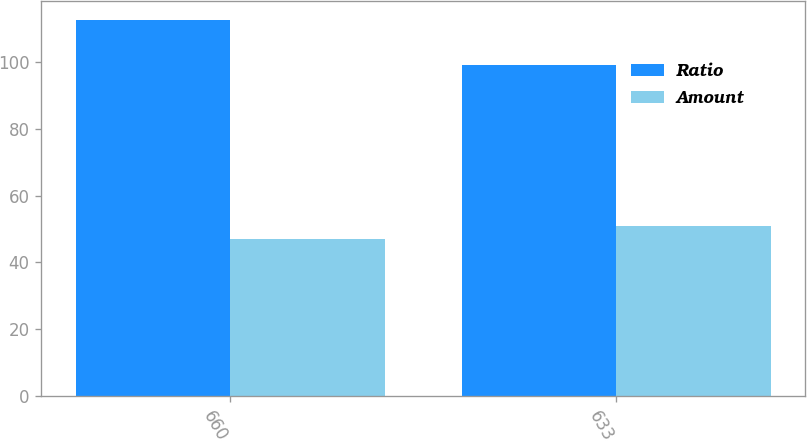Convert chart to OTSL. <chart><loc_0><loc_0><loc_500><loc_500><stacked_bar_chart><ecel><fcel>660<fcel>633<nl><fcel>Ratio<fcel>112.7<fcel>99.1<nl><fcel>Amount<fcel>47<fcel>51<nl></chart> 